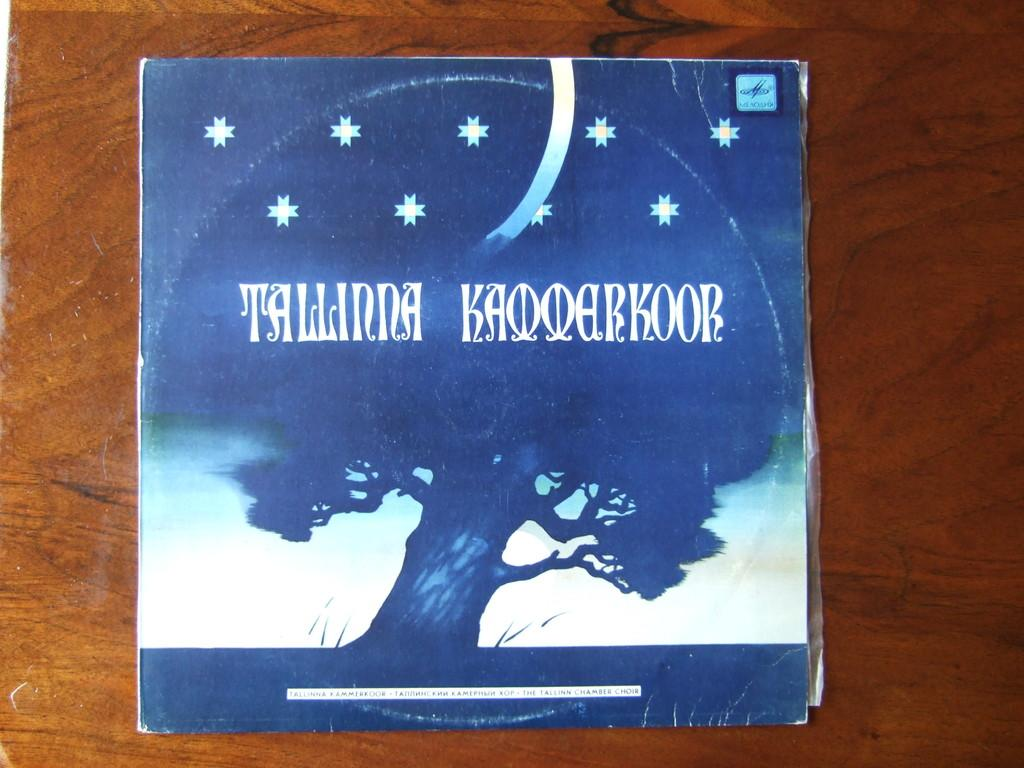<image>
Share a concise interpretation of the image provided. A cover with the word Tallinna also has a tree on it. 